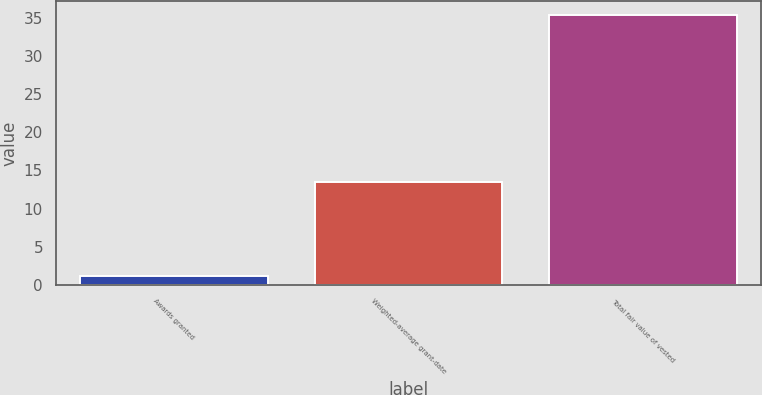<chart> <loc_0><loc_0><loc_500><loc_500><bar_chart><fcel>Awards granted<fcel>Weighted-average grant-date<fcel>Total fair value of vested<nl><fcel>1.1<fcel>13.51<fcel>35.4<nl></chart> 